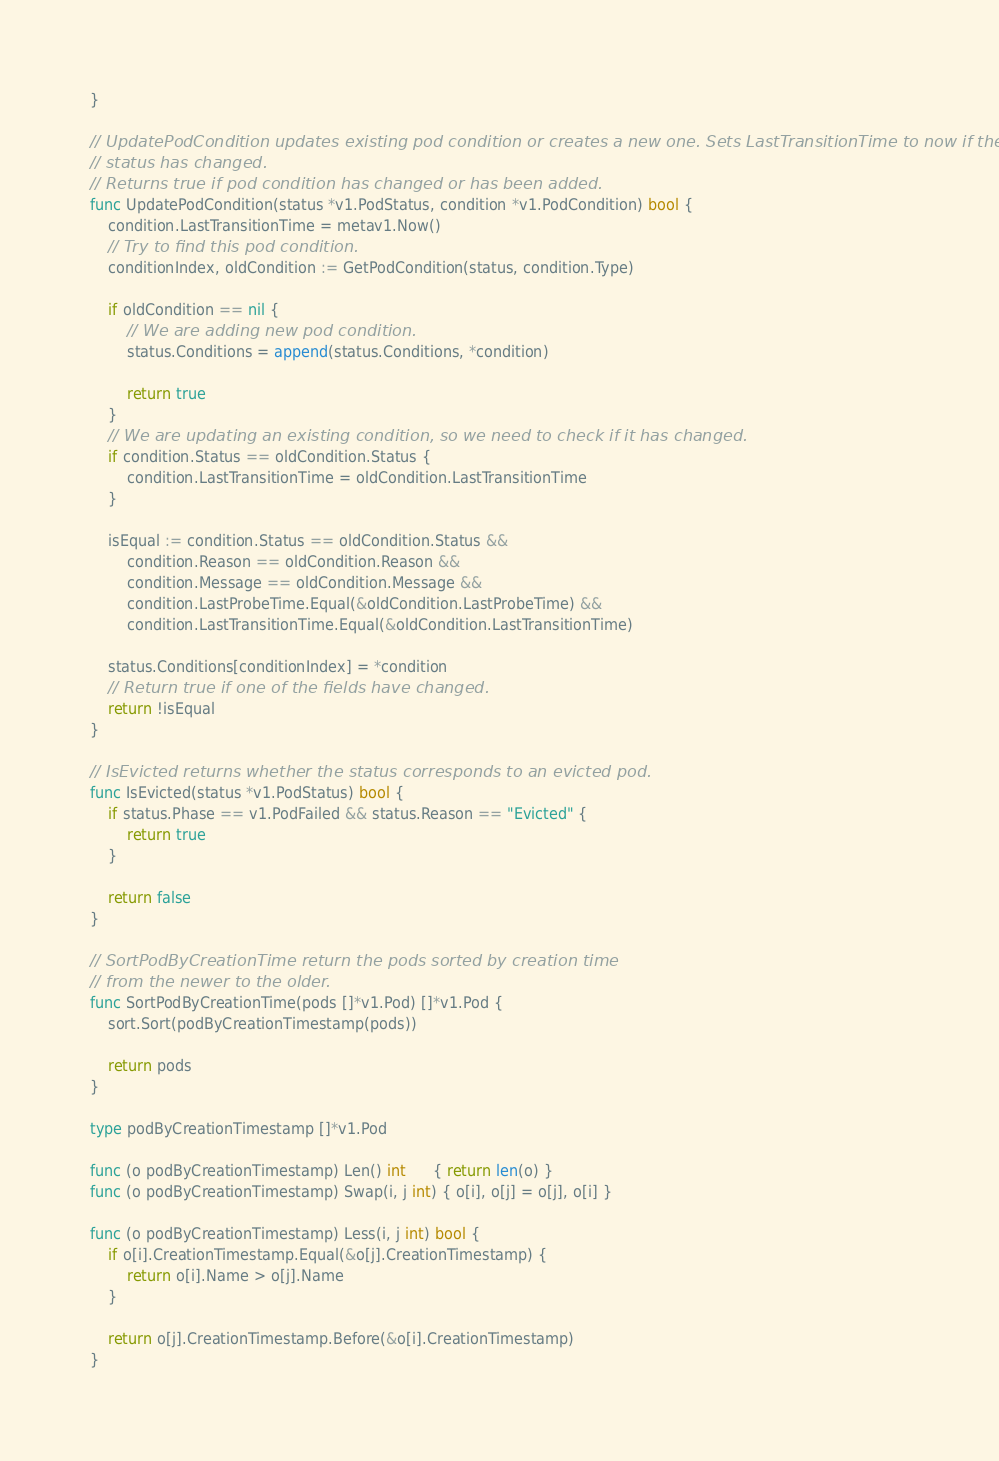Convert code to text. <code><loc_0><loc_0><loc_500><loc_500><_Go_>}

// UpdatePodCondition updates existing pod condition or creates a new one. Sets LastTransitionTime to now if the
// status has changed.
// Returns true if pod condition has changed or has been added.
func UpdatePodCondition(status *v1.PodStatus, condition *v1.PodCondition) bool {
	condition.LastTransitionTime = metav1.Now()
	// Try to find this pod condition.
	conditionIndex, oldCondition := GetPodCondition(status, condition.Type)

	if oldCondition == nil {
		// We are adding new pod condition.
		status.Conditions = append(status.Conditions, *condition)

		return true
	}
	// We are updating an existing condition, so we need to check if it has changed.
	if condition.Status == oldCondition.Status {
		condition.LastTransitionTime = oldCondition.LastTransitionTime
	}

	isEqual := condition.Status == oldCondition.Status &&
		condition.Reason == oldCondition.Reason &&
		condition.Message == oldCondition.Message &&
		condition.LastProbeTime.Equal(&oldCondition.LastProbeTime) &&
		condition.LastTransitionTime.Equal(&oldCondition.LastTransitionTime)

	status.Conditions[conditionIndex] = *condition
	// Return true if one of the fields have changed.
	return !isEqual
}

// IsEvicted returns whether the status corresponds to an evicted pod.
func IsEvicted(status *v1.PodStatus) bool {
	if status.Phase == v1.PodFailed && status.Reason == "Evicted" {
		return true
	}

	return false
}

// SortPodByCreationTime return the pods sorted by creation time
// from the newer to the older.
func SortPodByCreationTime(pods []*v1.Pod) []*v1.Pod {
	sort.Sort(podByCreationTimestamp(pods))

	return pods
}

type podByCreationTimestamp []*v1.Pod

func (o podByCreationTimestamp) Len() int      { return len(o) }
func (o podByCreationTimestamp) Swap(i, j int) { o[i], o[j] = o[j], o[i] }

func (o podByCreationTimestamp) Less(i, j int) bool {
	if o[i].CreationTimestamp.Equal(&o[j].CreationTimestamp) {
		return o[i].Name > o[j].Name
	}

	return o[j].CreationTimestamp.Before(&o[i].CreationTimestamp)
}
</code> 